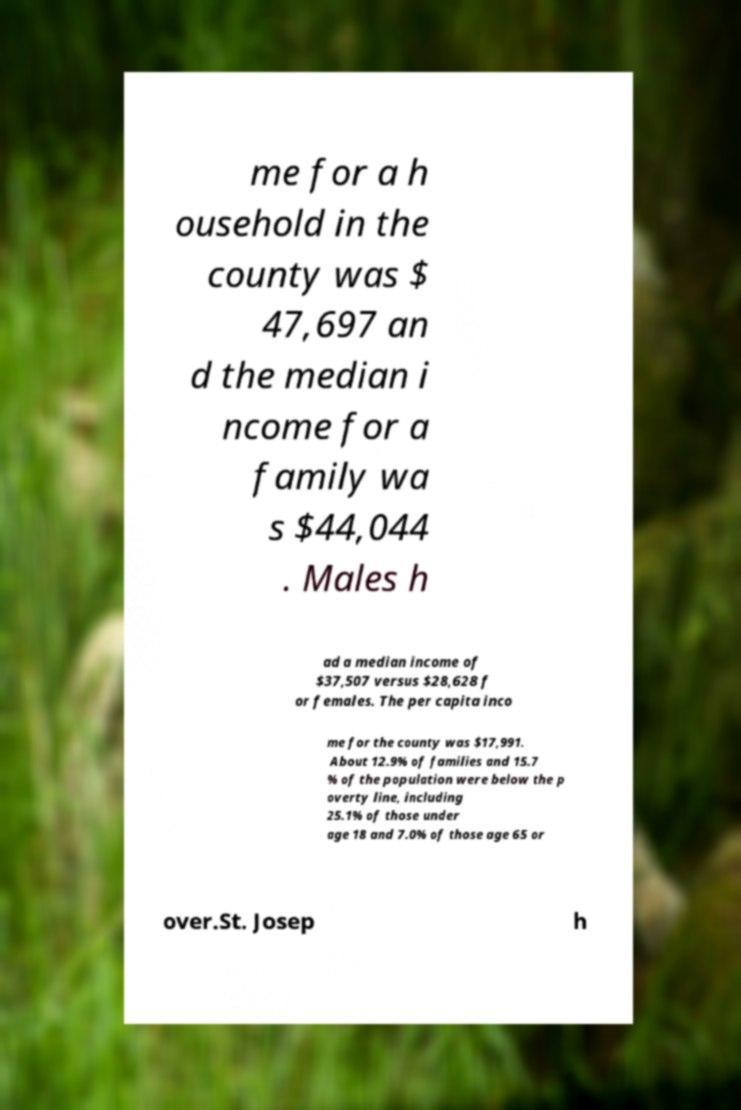Could you assist in decoding the text presented in this image and type it out clearly? me for a h ousehold in the county was $ 47,697 an d the median i ncome for a family wa s $44,044 . Males h ad a median income of $37,507 versus $28,628 f or females. The per capita inco me for the county was $17,991. About 12.9% of families and 15.7 % of the population were below the p overty line, including 25.1% of those under age 18 and 7.0% of those age 65 or over.St. Josep h 